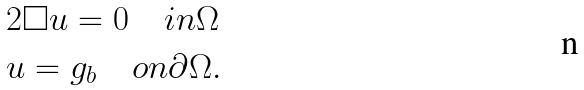Convert formula to latex. <formula><loc_0><loc_0><loc_500><loc_500>& 2 \square u = 0 \quad i n \Omega \\ & u = g _ { b } \quad o n \partial \Omega .</formula> 